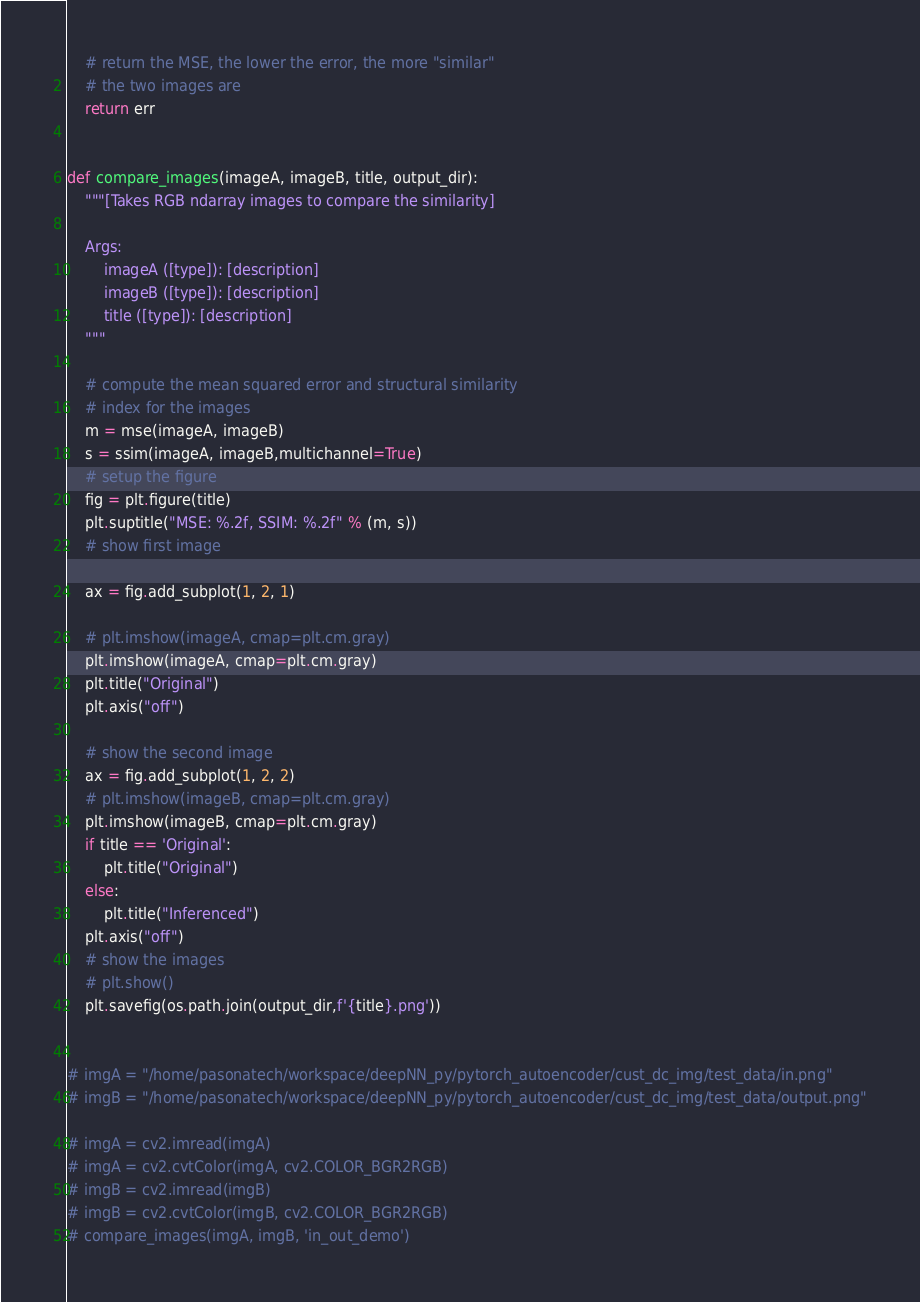<code> <loc_0><loc_0><loc_500><loc_500><_Python_>
	# return the MSE, the lower the error, the more "similar"
	# the two images are
	return err


def compare_images(imageA, imageB, title, output_dir):
    """[Takes RGB ndarray images to compare the similarity]

    Args:
        imageA ([type]): [description]
        imageB ([type]): [description]
        title ([type]): [description]
    """

    # compute the mean squared error and structural similarity
    # index for the images
    m = mse(imageA, imageB)
    s = ssim(imageA, imageB,multichannel=True)
    # setup the figure
    fig = plt.figure(title)
    plt.suptitle("MSE: %.2f, SSIM: %.2f" % (m, s))
    # show first image

    ax = fig.add_subplot(1, 2, 1)

    # plt.imshow(imageA, cmap=plt.cm.gray)
    plt.imshow(imageA, cmap=plt.cm.gray)
    plt.title("Original")
    plt.axis("off")

    # show the second image
    ax = fig.add_subplot(1, 2, 2)
    # plt.imshow(imageB, cmap=plt.cm.gray)
    plt.imshow(imageB, cmap=plt.cm.gray)
    if title == 'Original':
        plt.title("Original")
    else:
        plt.title("Inferenced")
    plt.axis("off")
    # show the images
    # plt.show()
    plt.savefig(os.path.join(output_dir,f'{title}.png'))


# imgA = "/home/pasonatech/workspace/deepNN_py/pytorch_autoencoder/cust_dc_img/test_data/in.png"
# imgB = "/home/pasonatech/workspace/deepNN_py/pytorch_autoencoder/cust_dc_img/test_data/output.png"

# imgA = cv2.imread(imgA)
# imgA = cv2.cvtColor(imgA, cv2.COLOR_BGR2RGB)
# imgB = cv2.imread(imgB)
# imgB = cv2.cvtColor(imgB, cv2.COLOR_BGR2RGB)
# compare_images(imgA, imgB, 'in_out_demo')
</code> 